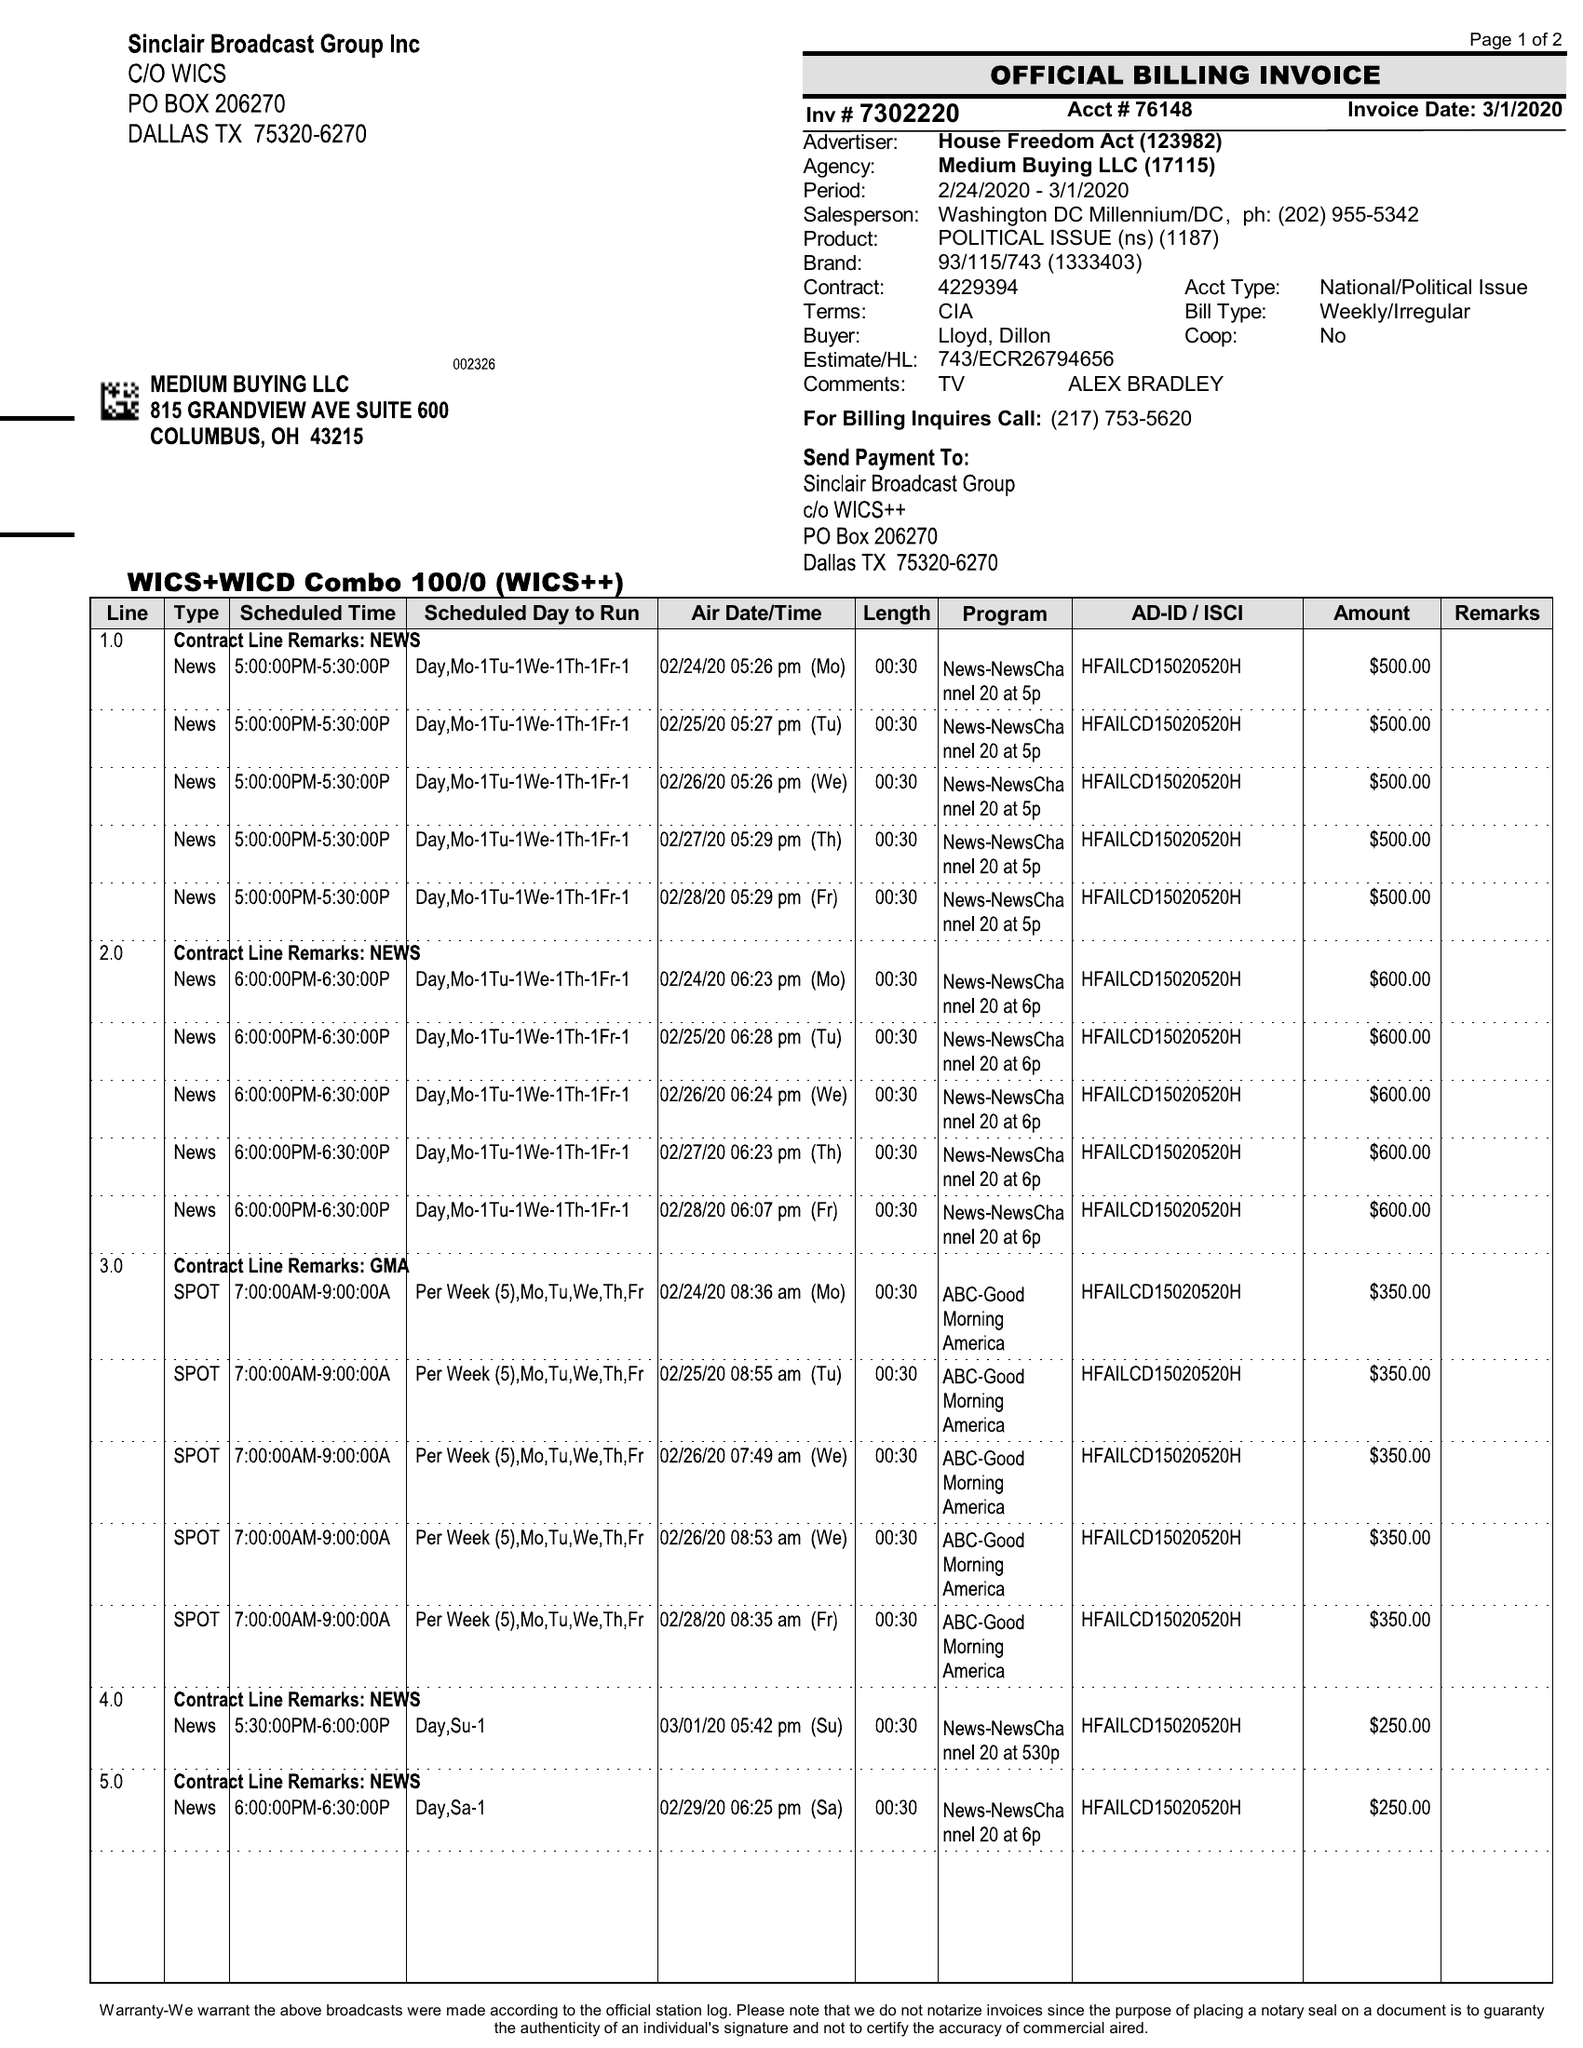What is the value for the advertiser?
Answer the question using a single word or phrase. HOUSE FREEDOM ACT 